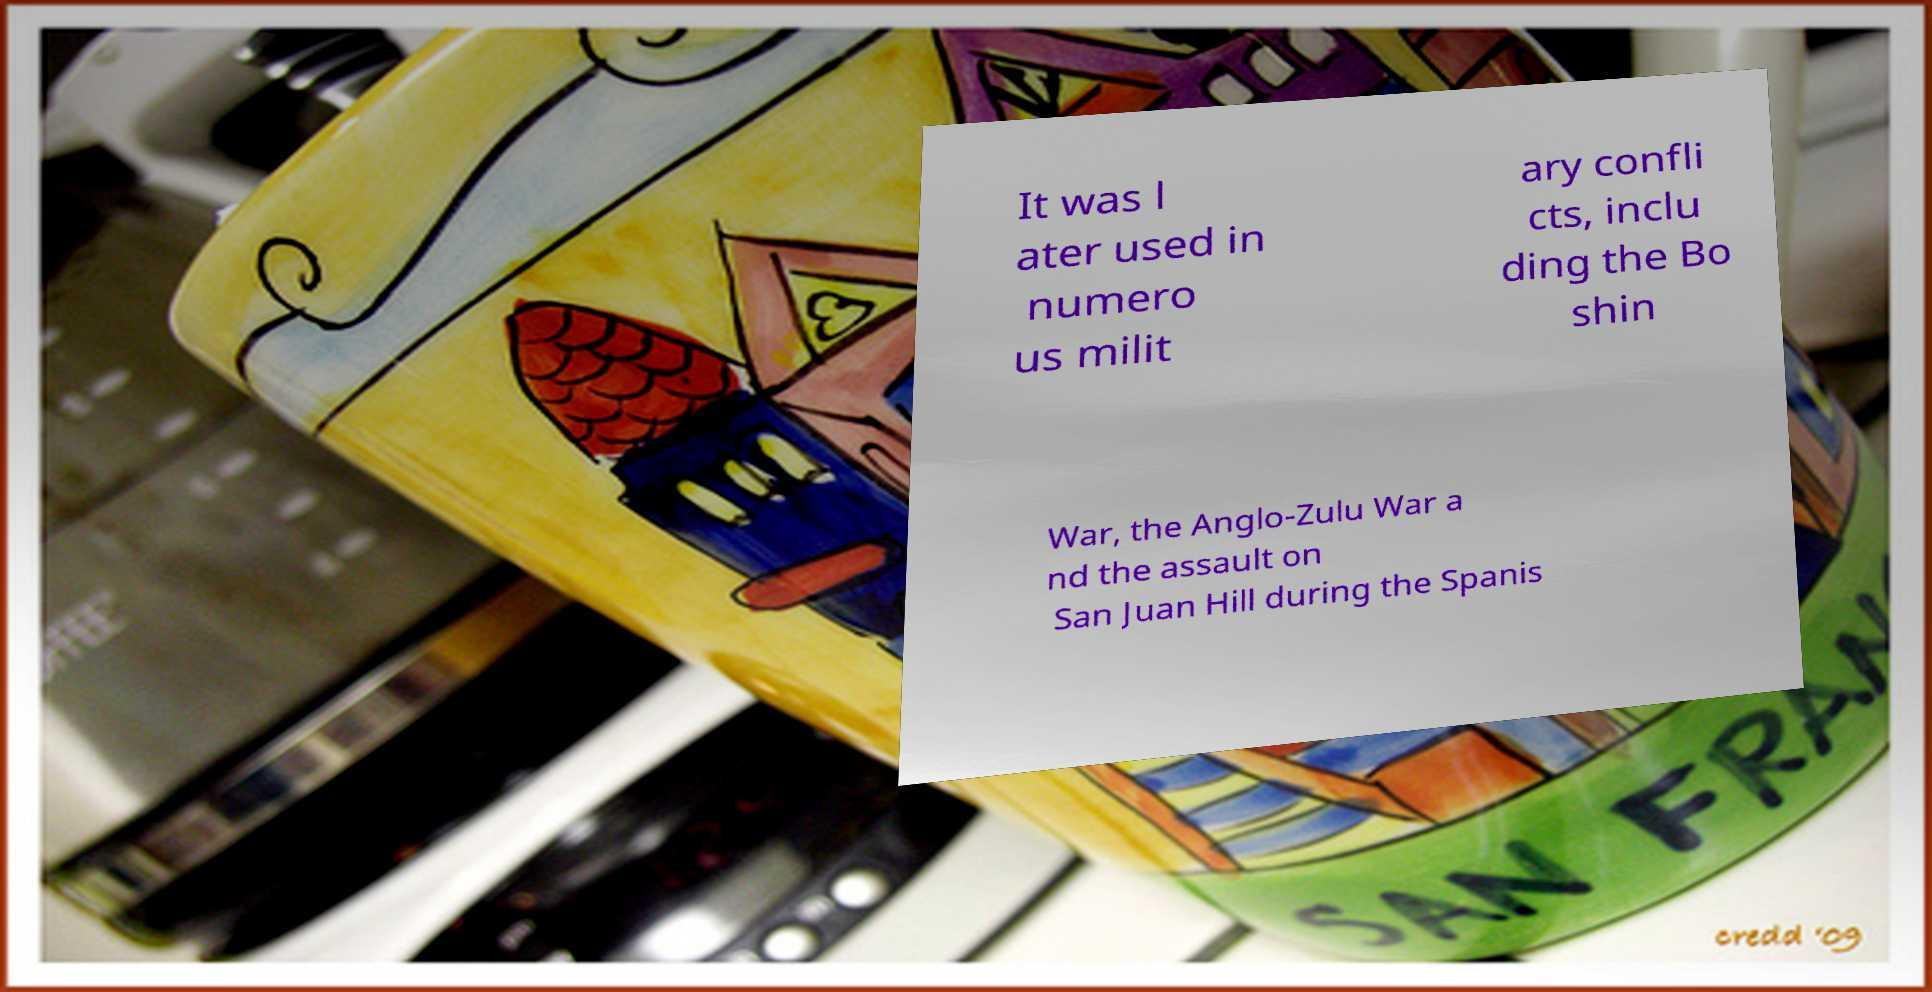For documentation purposes, I need the text within this image transcribed. Could you provide that? It was l ater used in numero us milit ary confli cts, inclu ding the Bo shin War, the Anglo-Zulu War a nd the assault on San Juan Hill during the Spanis 